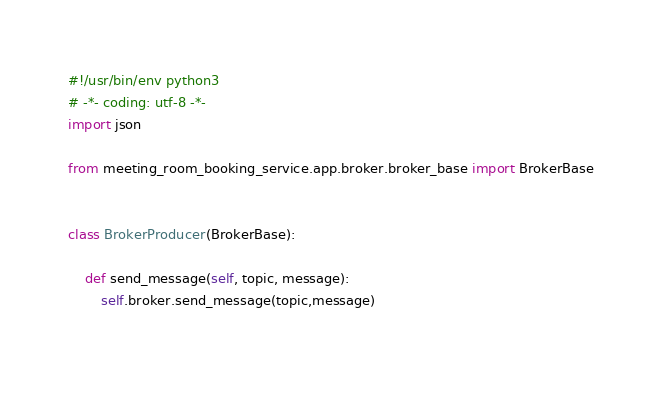Convert code to text. <code><loc_0><loc_0><loc_500><loc_500><_Python_>#!/usr/bin/env python3
# -*- coding: utf-8 -*-
import json

from meeting_room_booking_service.app.broker.broker_base import BrokerBase


class BrokerProducer(BrokerBase):

    def send_message(self, topic, message):
        self.broker.send_message(topic,message)
    </code> 